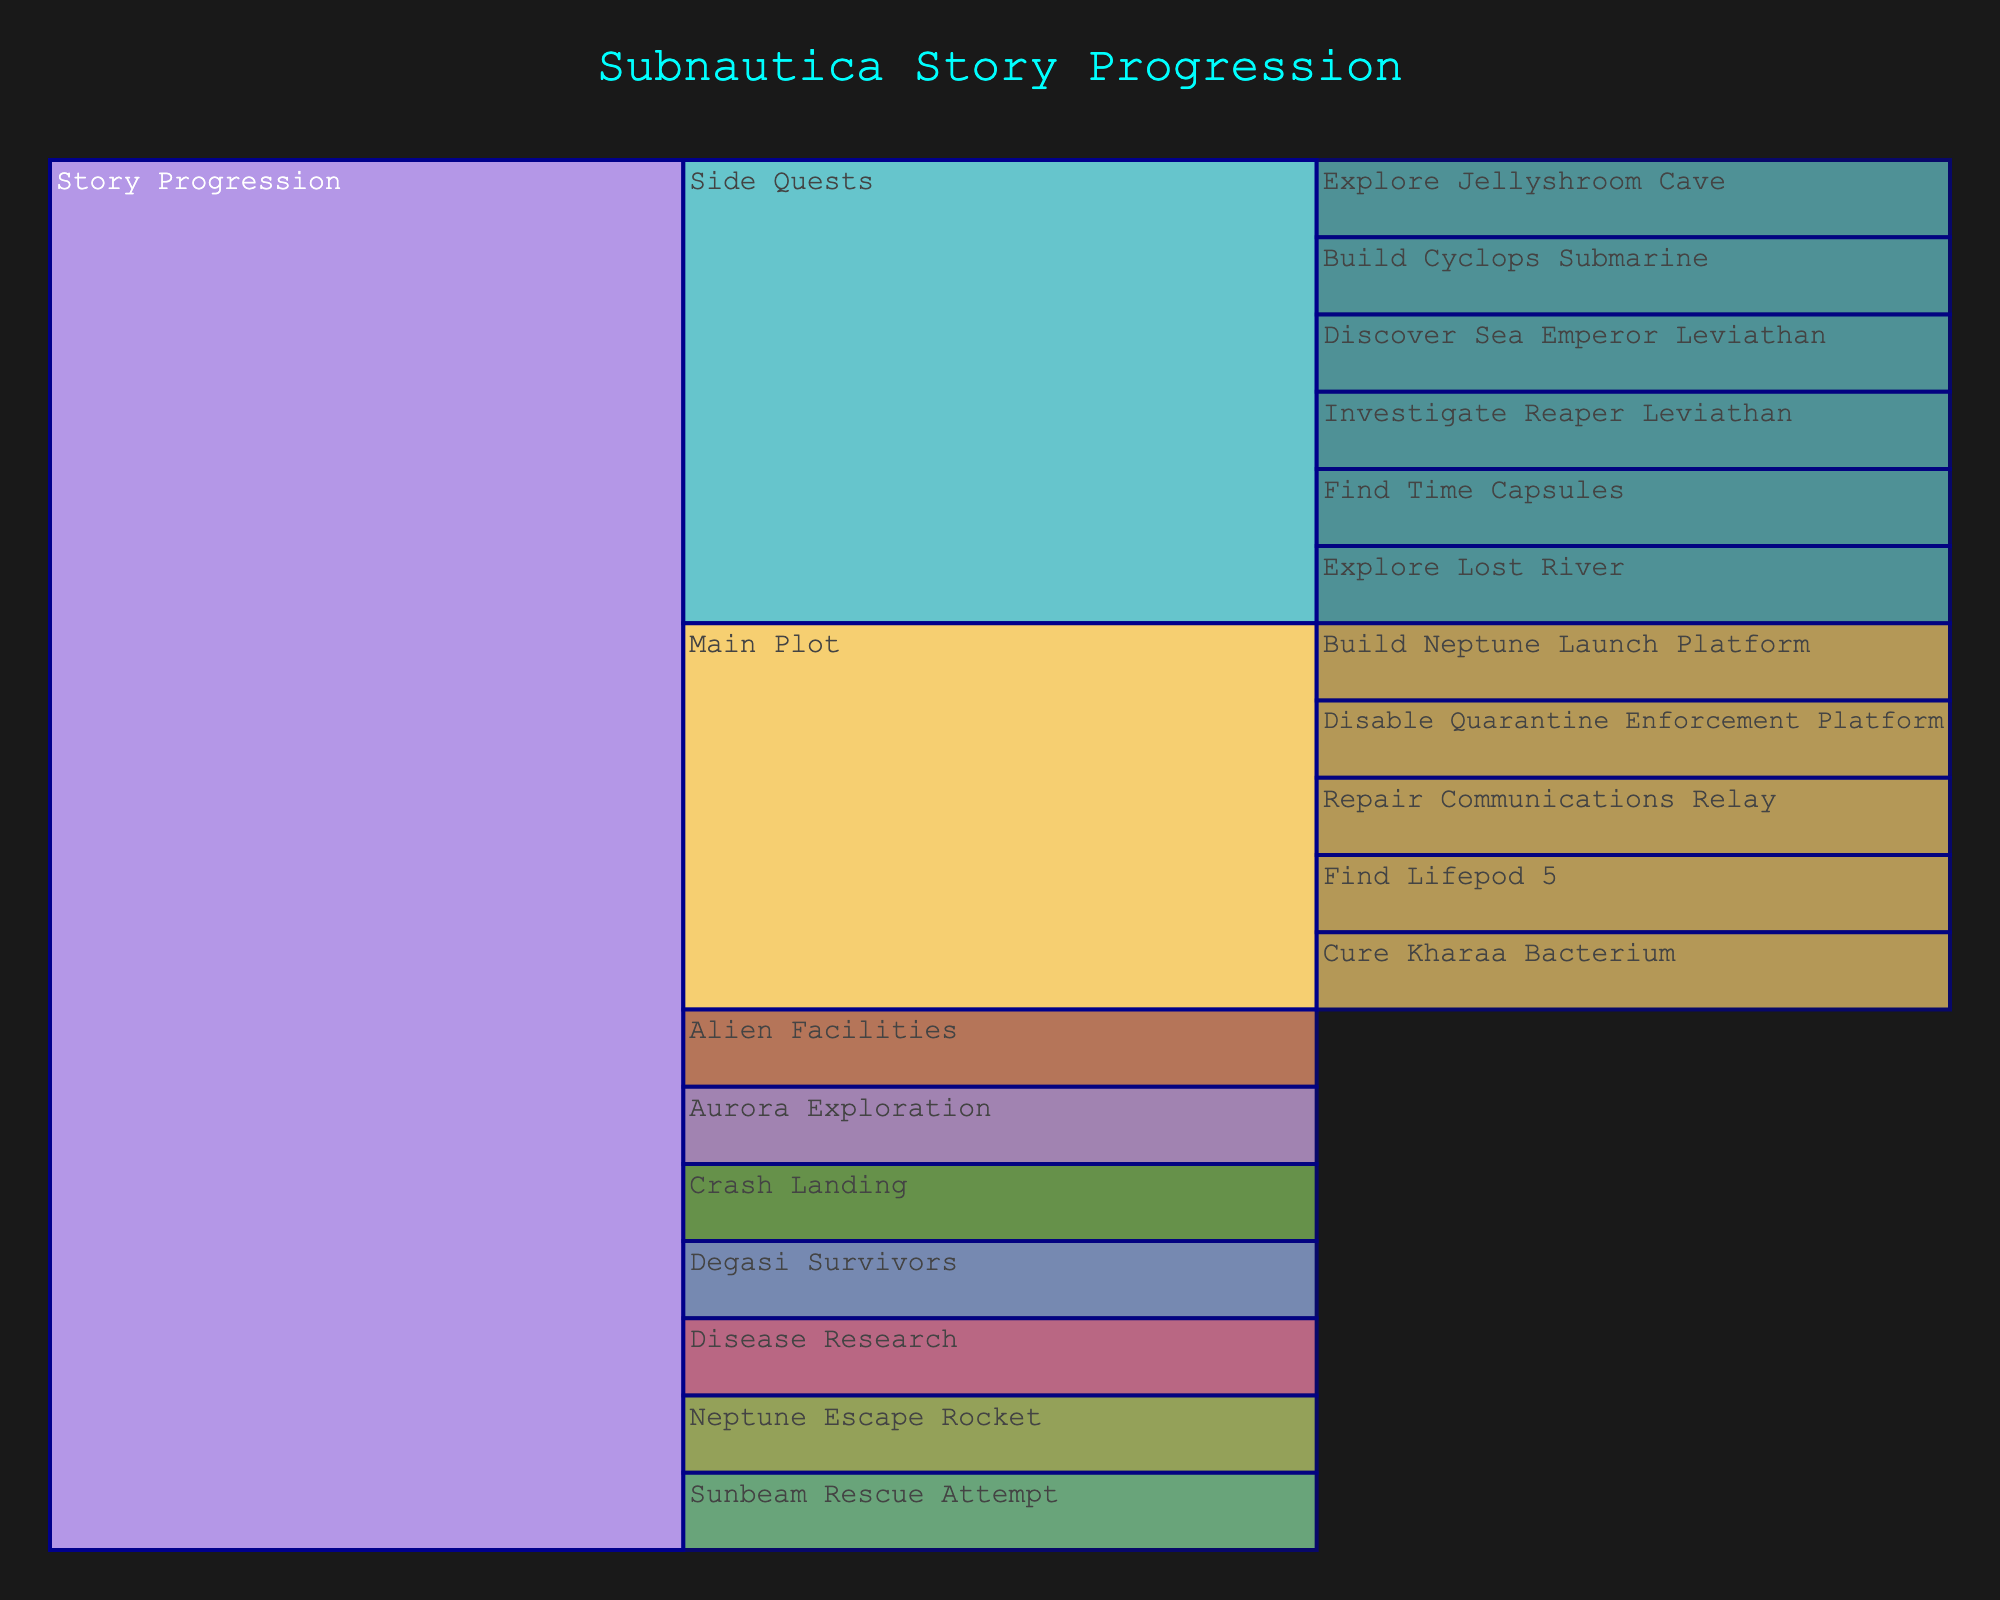What is the main title of the figure? The main title of the figure is displayed at the top and provides an overview of the figure's content. In this case, it describes the overall theme of the visual representation.
Answer: Subnautica Story Progression What are the major plot points under the "Main Plot" section? By looking at the "Main Plot" section and examining the nodes branching from it, we identify the significant steps in the main storyline. These nodes will be located in the second level below "Story Progression" under "Main Plot."
Answer: Find Lifepod 5, Repair Communications Relay, Disable Quarantine Enforcement Platform, Cure Kharaa Bacterium, Build Neptune Launch Platform How many side quests are listed in the "Side Quests" section? To find the number of side quests, count the nodes branching directly from the "Side Quests" in the Icicle Chart. These nodes represent individual side quests.
Answer: 6 Which main plot point must be completed before curing the Kharaa Bacterium? From the icicle chart structure, identify which nodes are hierarchically before "Cure Kharaa Bacterium" under the Main Plot. These steps need to be completed earlier in the storyline.
Answer: Disable Quarantine Enforcement Platform What is the relationship between exploring the Aurora and the degasi survivors? To answer this, look at the placement of "Aurora Exploration" and "Degasi Survivors" in the chart to see if they are in the same branch or different branches of the main plotline.
Answer: Separate branches What is the first main plot point according to the chart? Identify the initial step in the main plotline progression by locating the first node under the Main Plot section.
Answer: Find Lifepod 5 Which side quest involves a specific type of Leviathan? Explore the labels under the "Side Quests" section to find any mention of Leviathan species, which indicates a side quest related to Leviathans.
Answer: Investigate Reaper Leviathan, Discover Sea Emperor Leviathan How many plot points are there in total in the chart? Count all distinct nodes at each level of the chart, including nodes under Main Plot and Side Quests branches, starting from the root "Story Progression."
Answer: 16 